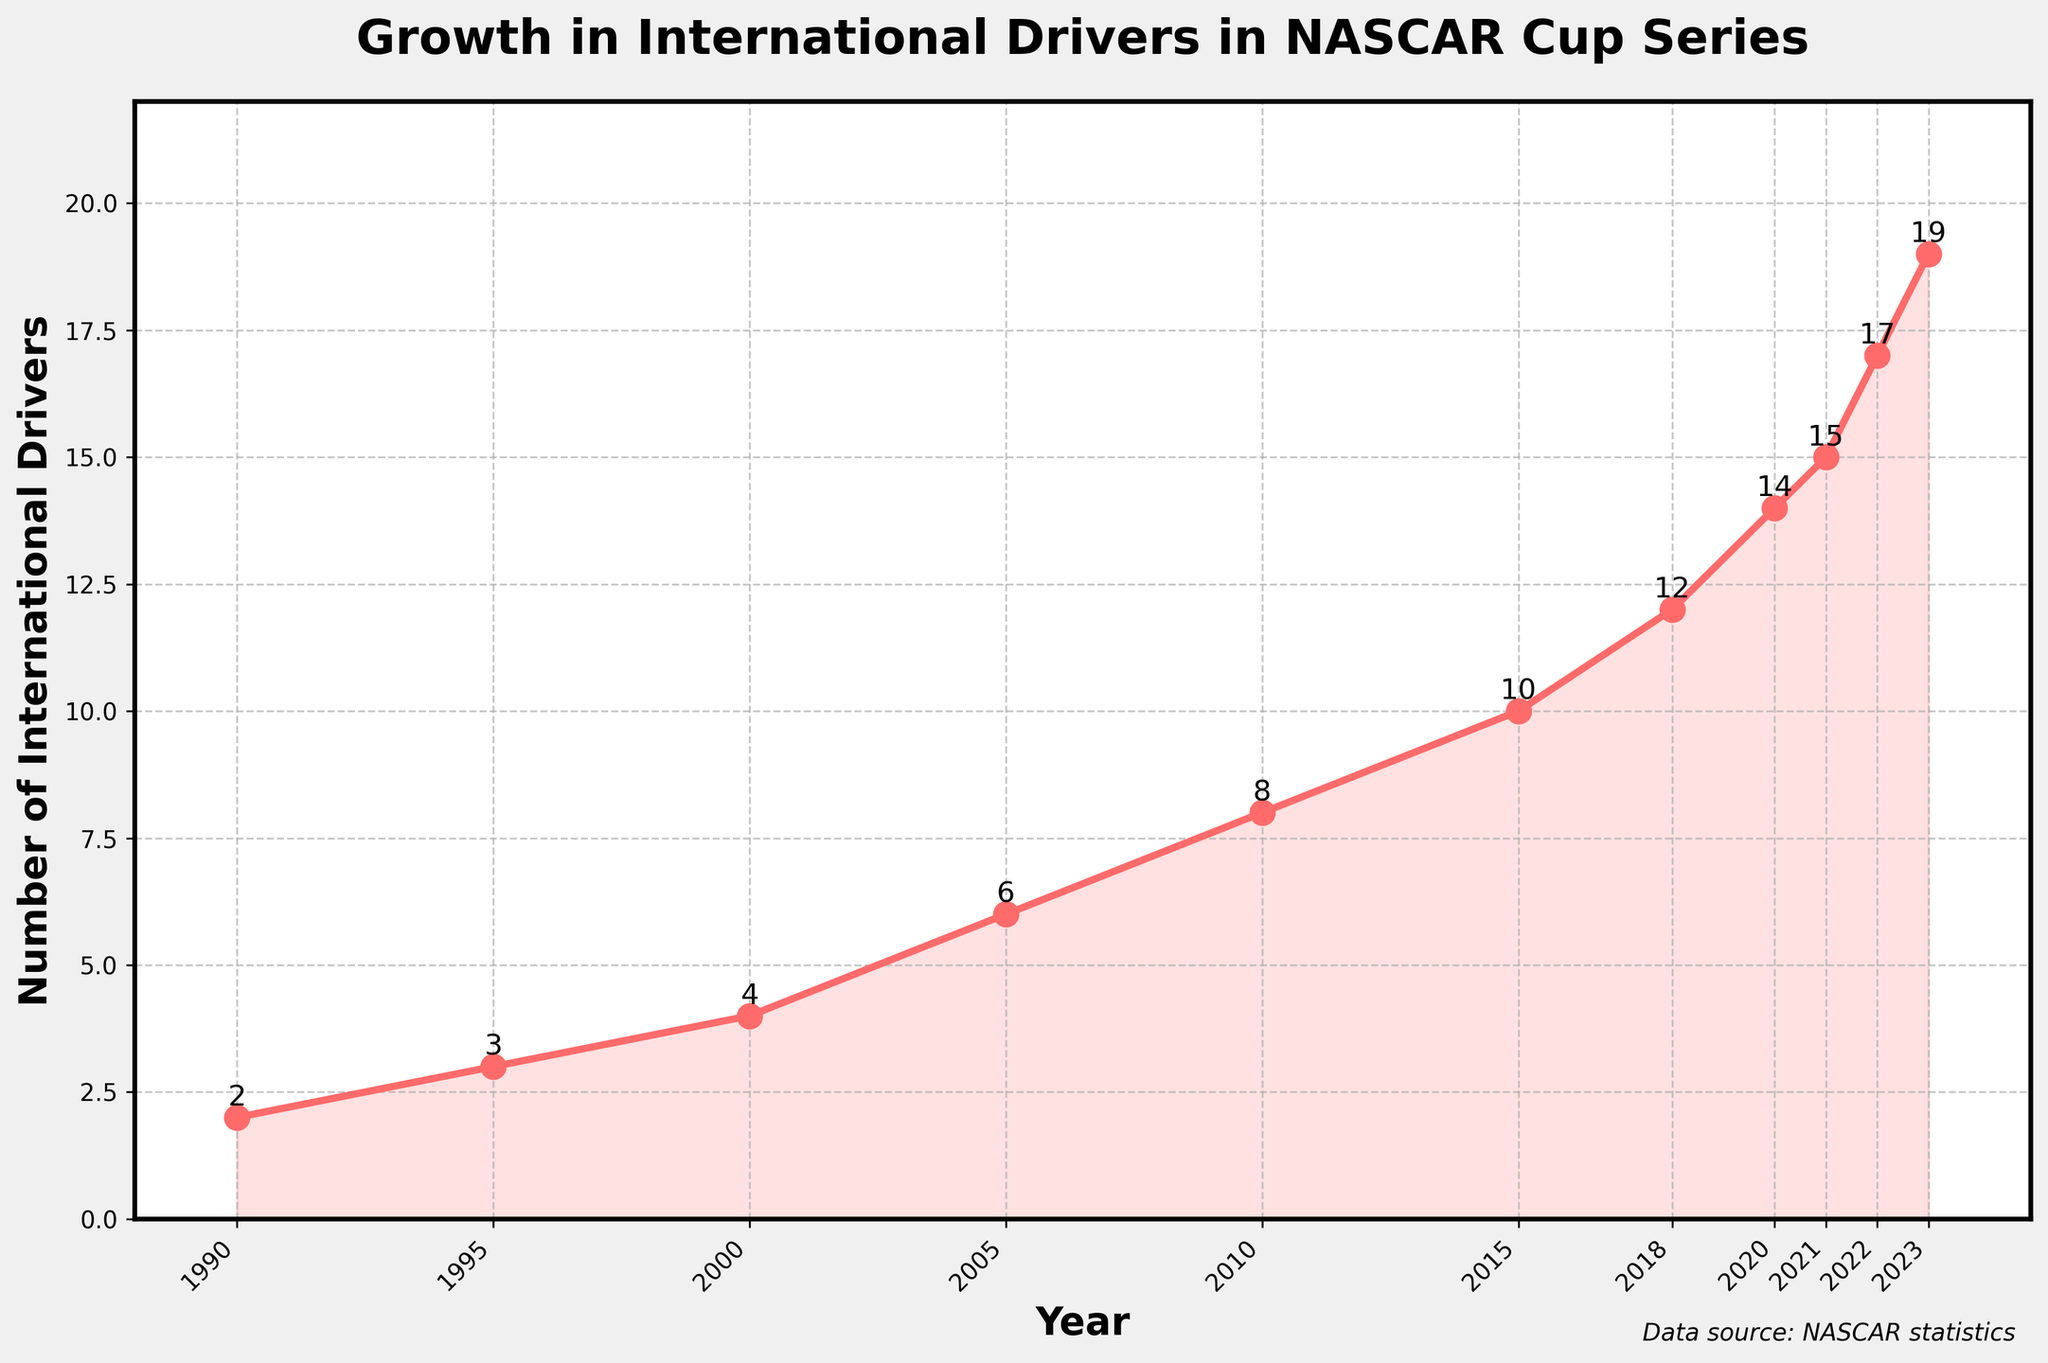What is the increase in the number of international drivers from 2000 to 2020? There were 4 international drivers in 2000 and 14 in 2020. So, the increase is calculated by subtracting 4 from 14.
Answer: 10 Which year had the most significant increase in the number of international drivers compared to the previous year? By analyzing the line chart, we can see that the largest single increase occurred between 2021 (15 drivers) and 2022 (17 drivers), representing an increase of 2 drivers.
Answer: 2022 In what year did the number of international drivers double from what it was in 2005? In 2005, there were 6 drivers. Doubling this number gives us 12 drivers, which was reached in 2018.
Answer: 2018 Between 2018 and 2023, what is the average annual increase in the number of international drivers? The number of drivers in 2018 was 12 and in 2023 was 19. The increase over 5 years is 7 drivers (19 - 12). The average annual increase is 7 divided by 5.
Answer: 1.4 How many years did it take for the number of international drivers to go from 8 to 17? The number of drivers was 8 in 2010 and 17 in 2022. The number of years between 2010 and 2022 is 12 years.
Answer: 12 What is the median number of international drivers over the entire period from 1990 to 2023? Listing the number of drivers: [2, 3, 4, 6, 8, 10, 12, 14, 15, 17, 19], the median value is the middle value, which is 10.
Answer: 10 Which year had an equal number of international drivers as the number of drivers in 2021? The number of drivers in 2021 was 15. Referring to the previous years, no year had exactly 15 drivers before 2021.
Answer: None Visualize the color and overall trend shown in the line chart. What does it signify? The line and shaded area in red show a consistently upward trend from 1990 to 2023, indicating a steady increase in the number of international drivers throughout the years.
Answer: Steady increase Between which consecutive years is the slope of the line steepest indicating the fastest growth? The zig-zagging line is steepest between 2018 (12 drivers) and 2020 (14 drivers), indicating the fastest growth during this period, the increase is more noticeable.
Answer: 2018 to 2020 Compare the increase in the number of international drivers from 1990 to 2000 with the increase from 2000 to 2022. Which period had a higher increase? From 1990 (2 drivers) to 2000 (4 drivers) the increase is 2 drivers. From 2000 (4 drivers) to 2022 (17 drivers) the increase is 13 drivers. Clearly, the second period had a higher increase.
Answer: 2000 to 2022 